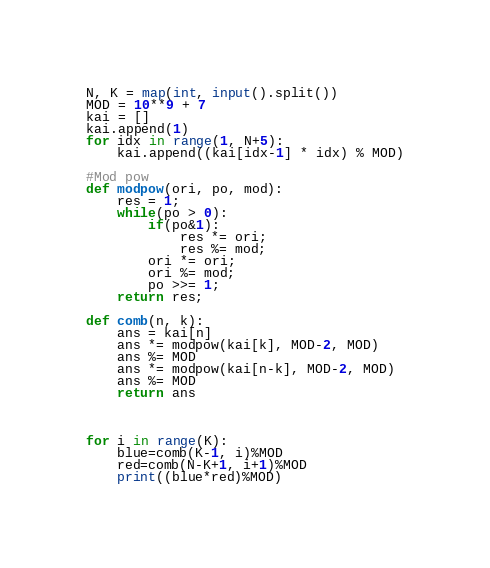Convert code to text. <code><loc_0><loc_0><loc_500><loc_500><_Python_>N, K = map(int, input().split())
MOD = 10**9 + 7
kai = []
kai.append(1)
for idx in range(1, N+5):
	kai.append((kai[idx-1] * idx) % MOD)

#Mod pow
def modpow(ori, po, mod):
	res = 1;
	while(po > 0):
		if(po&1):
			res *= ori;
			res %= mod;
		ori *= ori;
		ori %= mod;
		po >>= 1;
	return res;

def comb(n, k):
	ans = kai[n]
	ans *= modpow(kai[k], MOD-2, MOD)
	ans %= MOD
	ans *= modpow(kai[n-k], MOD-2, MOD)
	ans %= MOD
	return ans



for i in range(K):
	blue=comb(K-1, i)%MOD
	red=comb(N-K+1, i+1)%MOD
	print((blue*red)%MOD)</code> 